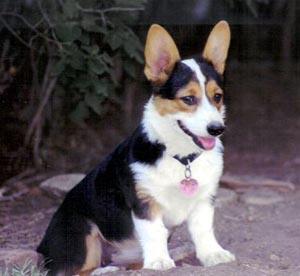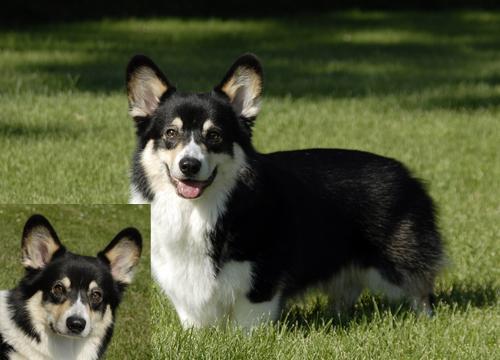The first image is the image on the left, the second image is the image on the right. Evaluate the accuracy of this statement regarding the images: "the left image has a sitting dog with its' tongue out". Is it true? Answer yes or no. Yes. The first image is the image on the left, the second image is the image on the right. Examine the images to the left and right. Is the description "One dog is looking to the right." accurate? Answer yes or no. Yes. 